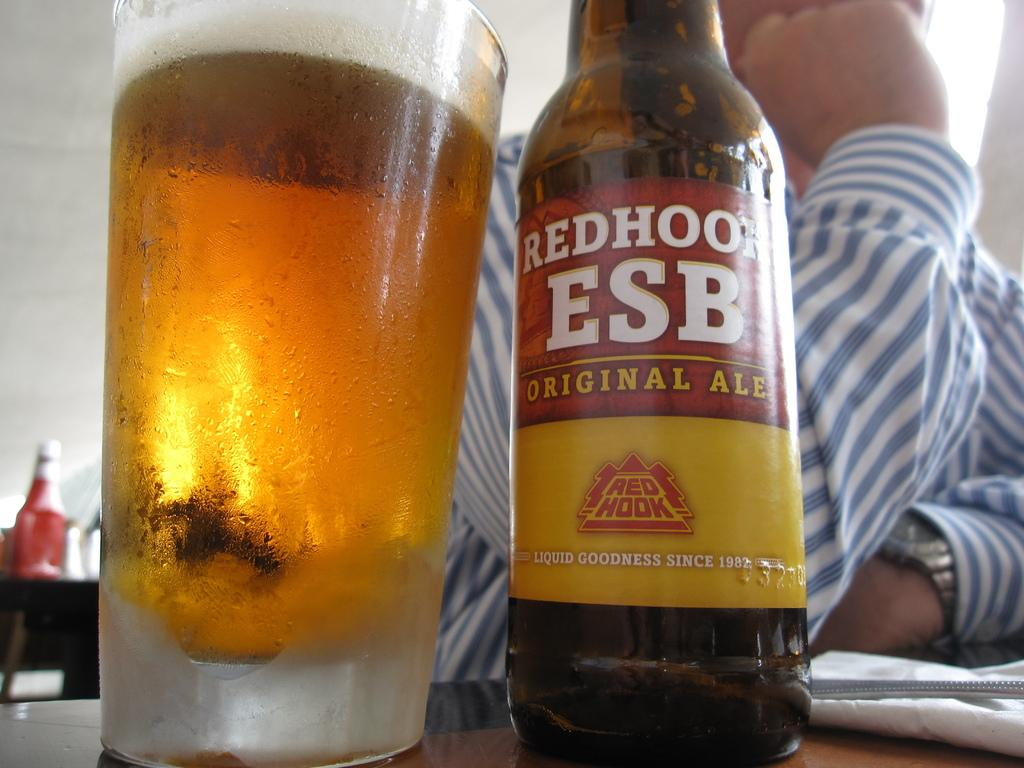<image>
Describe the image concisely. A bottle of RedHook Original Ale has been poured into a glass 